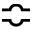<formula> <loc_0><loc_0><loc_500><loc_500>\ B u m p e q</formula> 